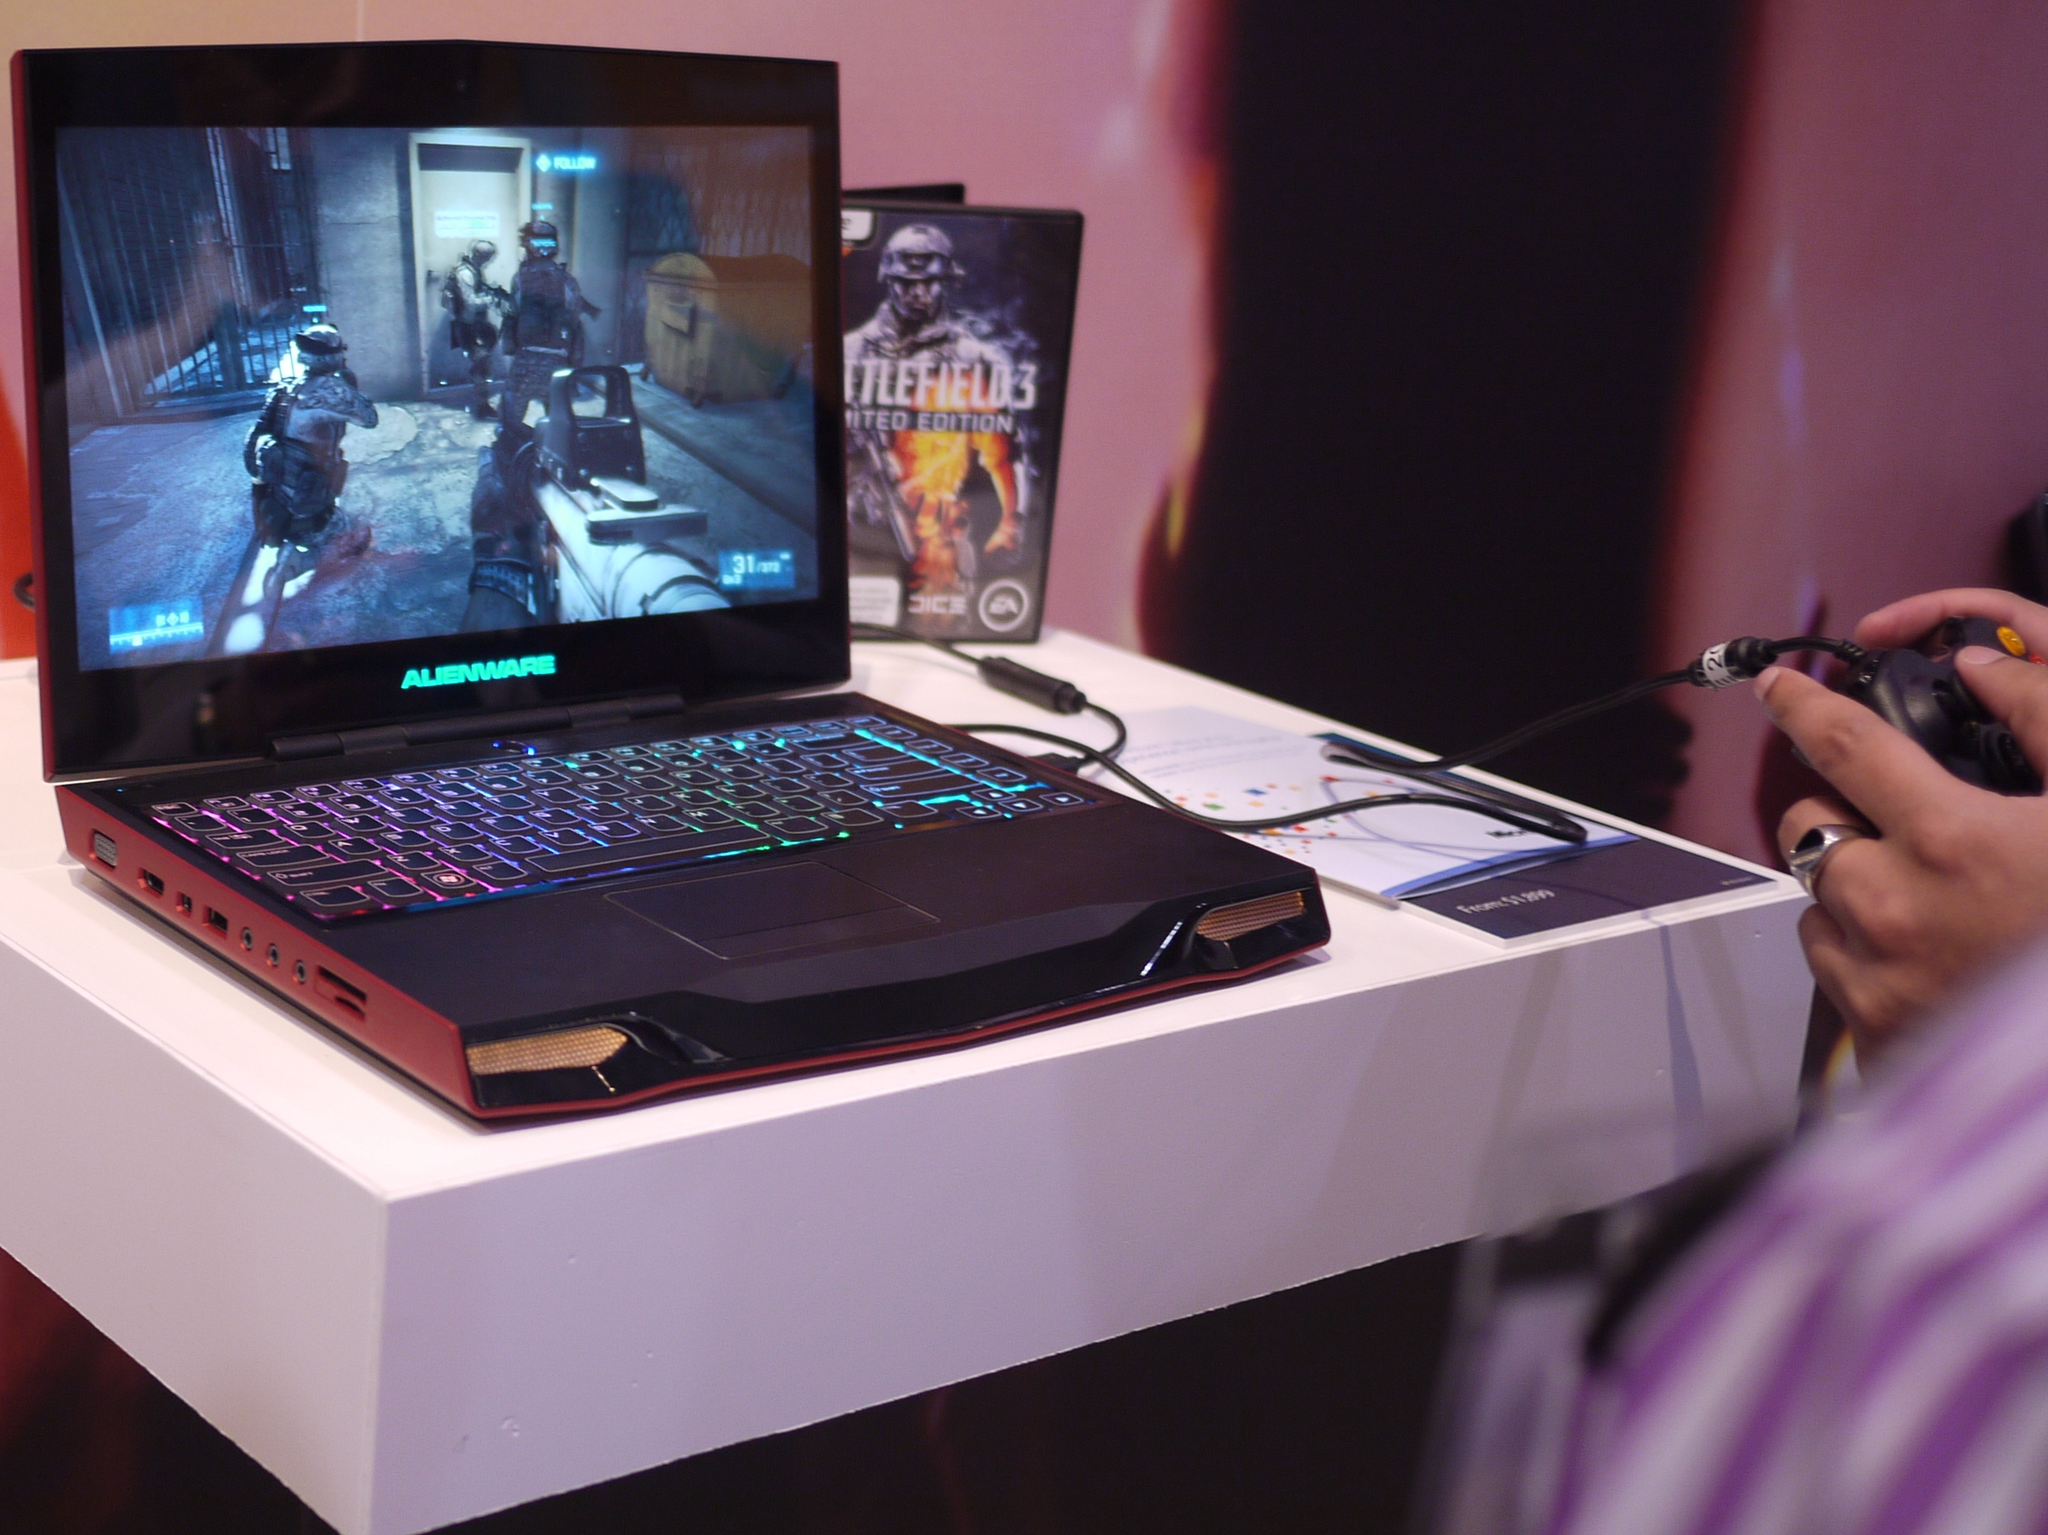<image>
Give a short and clear explanation of the subsequent image. an opened alienware laptop computer with battlefield 3 limited edition case behind it 